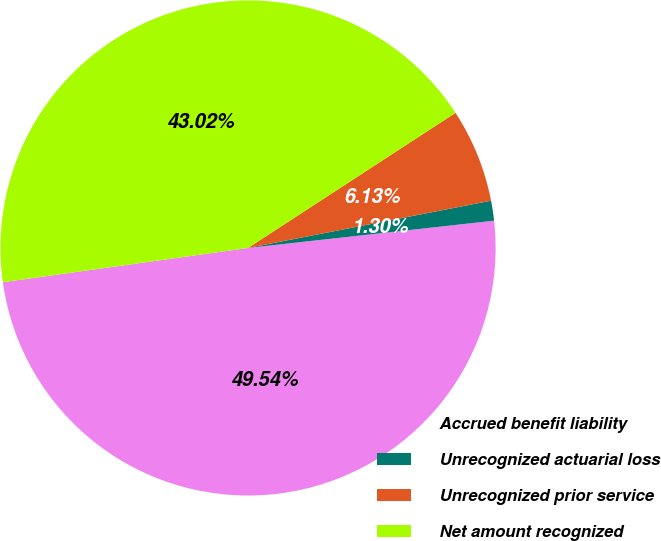Convert chart to OTSL. <chart><loc_0><loc_0><loc_500><loc_500><pie_chart><fcel>Accrued benefit liability<fcel>Unrecognized actuarial loss<fcel>Unrecognized prior service<fcel>Net amount recognized<nl><fcel>49.54%<fcel>1.3%<fcel>6.13%<fcel>43.02%<nl></chart> 